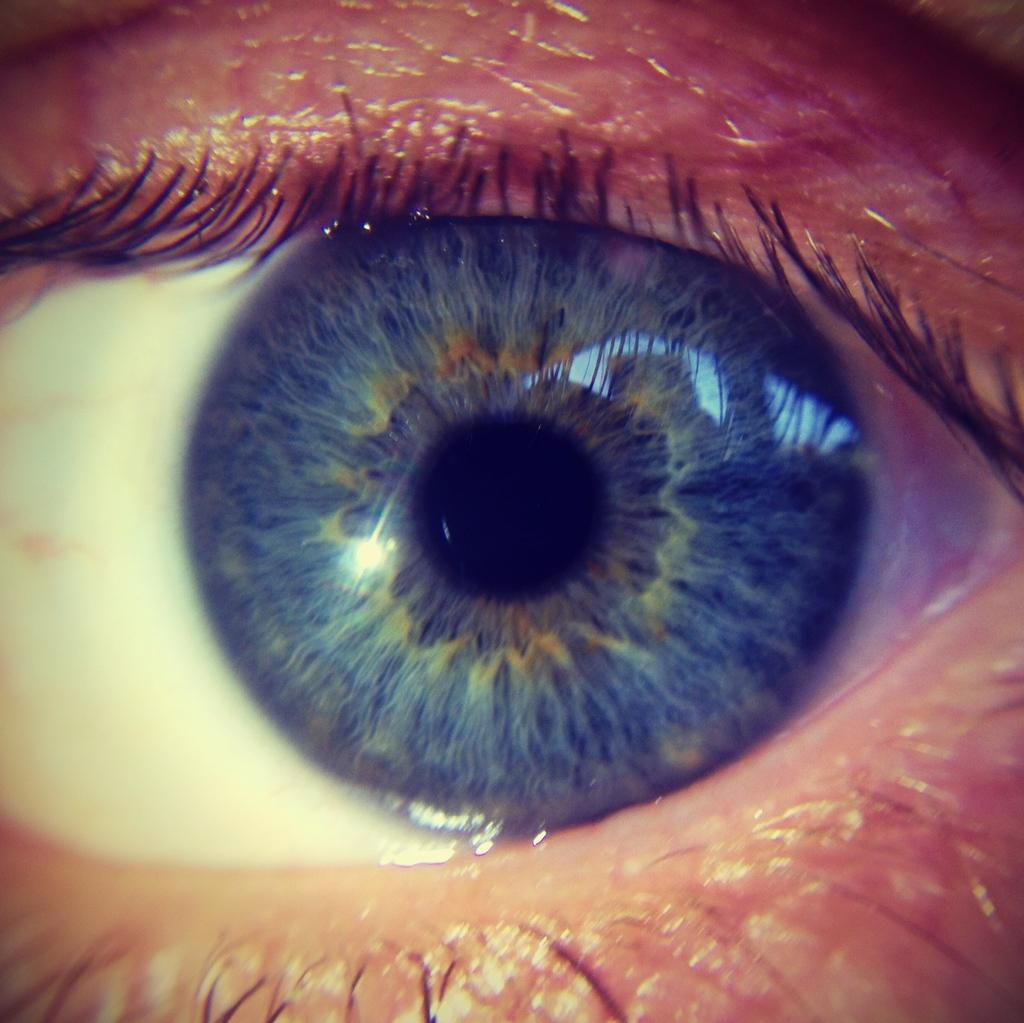What is the main subject of the image? The main subject of the image is the eye of a person. Can you describe the eye in the image? The eye appears to be open and has a visible iris and pupil. How many questions are being asked in the image? There are no questions visible in the image; it only features the eye of a person. 